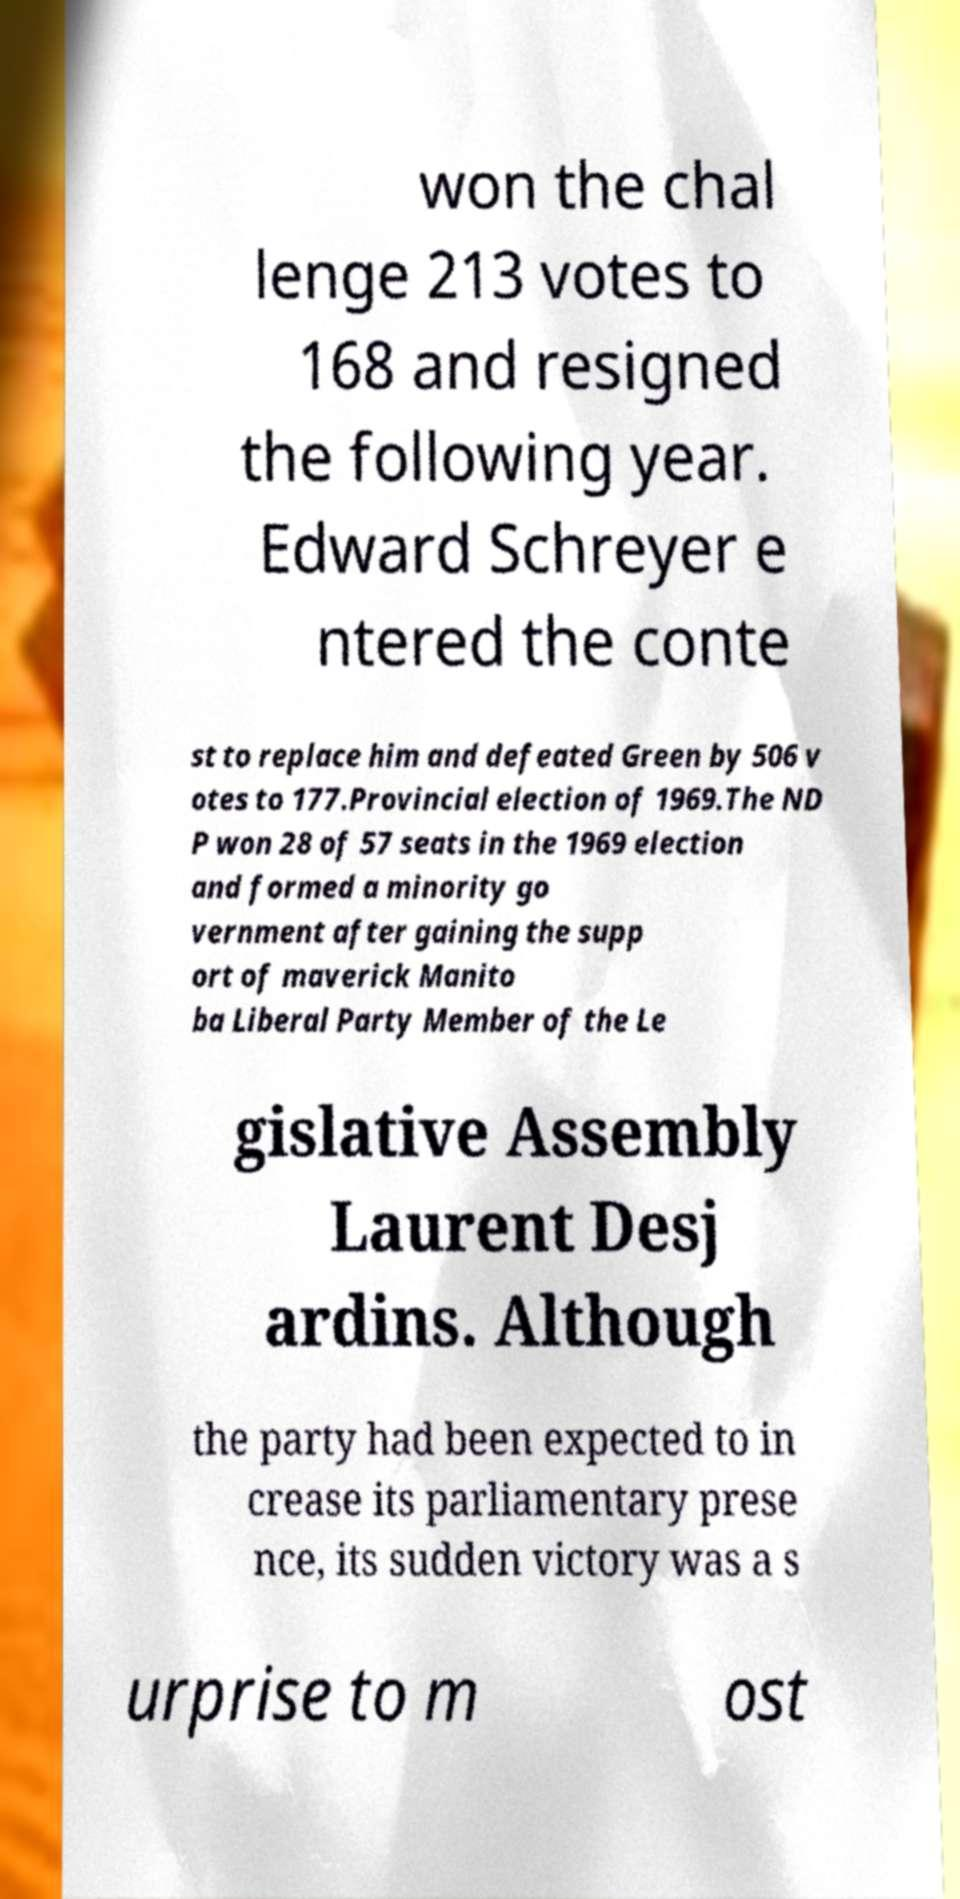Please read and relay the text visible in this image. What does it say? won the chal lenge 213 votes to 168 and resigned the following year. Edward Schreyer e ntered the conte st to replace him and defeated Green by 506 v otes to 177.Provincial election of 1969.The ND P won 28 of 57 seats in the 1969 election and formed a minority go vernment after gaining the supp ort of maverick Manito ba Liberal Party Member of the Le gislative Assembly Laurent Desj ardins. Although the party had been expected to in crease its parliamentary prese nce, its sudden victory was a s urprise to m ost 